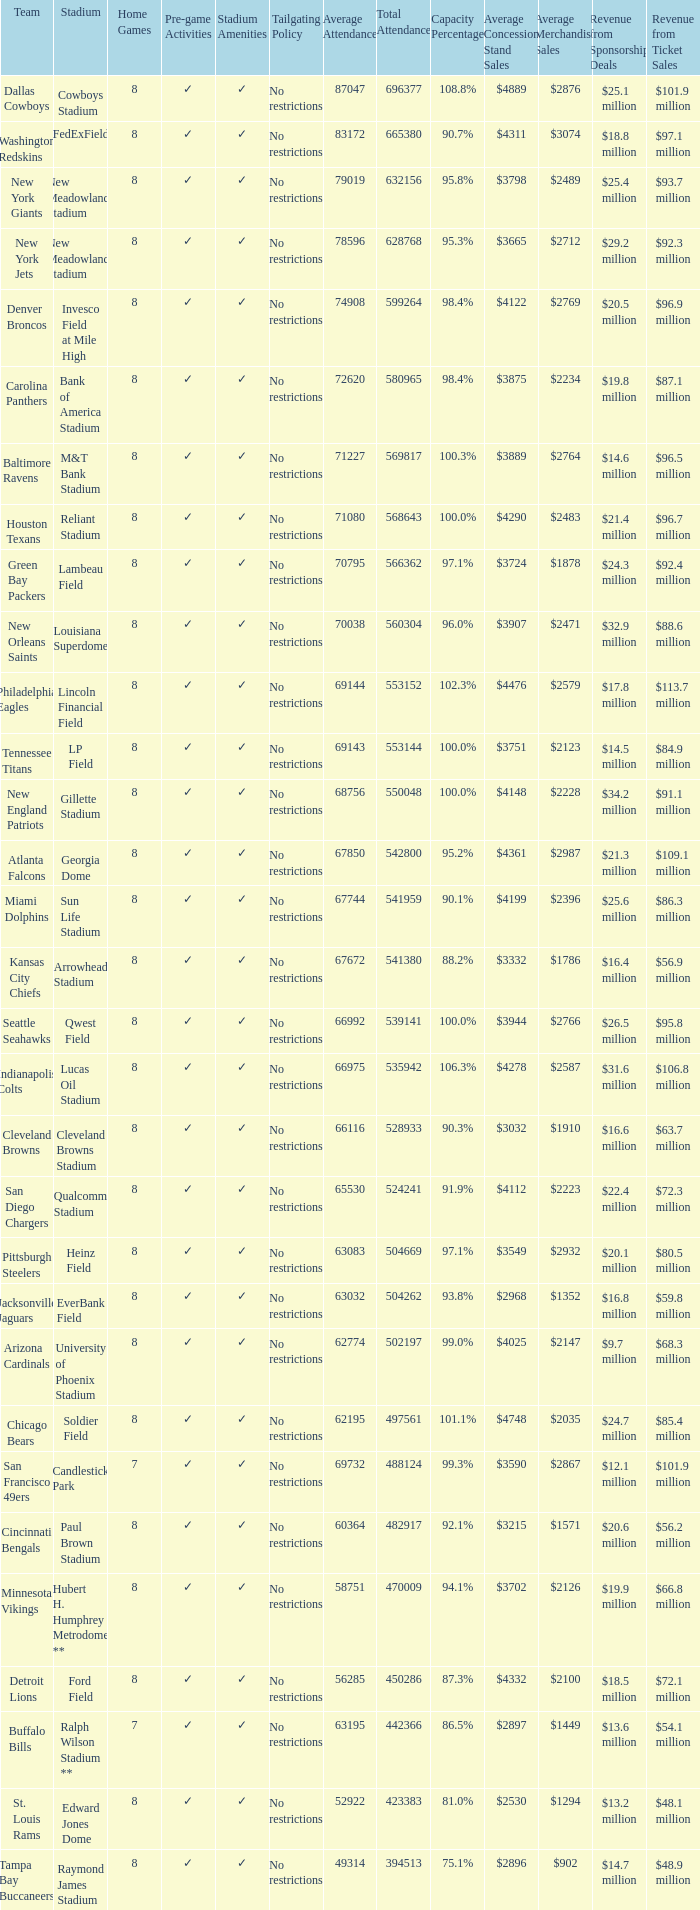What was the total attendance of the New York Giants? 632156.0. 